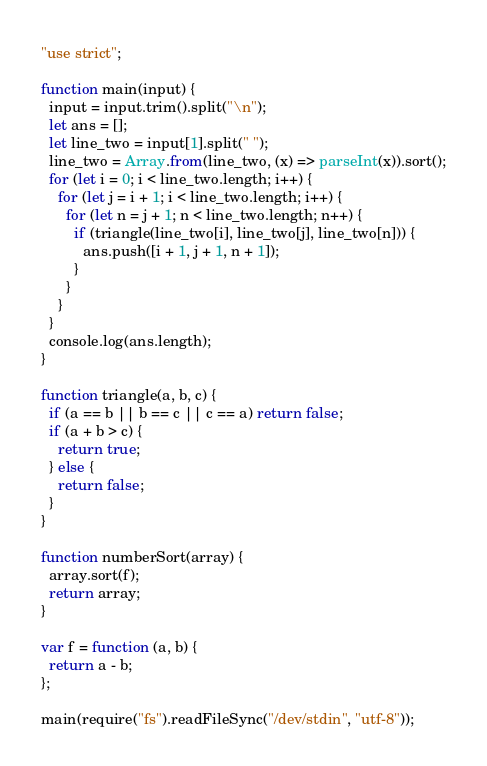Convert code to text. <code><loc_0><loc_0><loc_500><loc_500><_JavaScript_>"use strict";

function main(input) {
  input = input.trim().split("\n");
  let ans = [];
  let line_two = input[1].split(" ");
  line_two = Array.from(line_two, (x) => parseInt(x)).sort();
  for (let i = 0; i < line_two.length; i++) {
    for (let j = i + 1; i < line_two.length; i++) {
      for (let n = j + 1; n < line_two.length; n++) {
        if (triangle(line_two[i], line_two[j], line_two[n])) {
          ans.push([i + 1, j + 1, n + 1]);
        }
      }
    }
  }
  console.log(ans.length);
}

function triangle(a, b, c) {
  if (a == b || b == c || c == a) return false;
  if (a + b > c) {
    return true;
  } else {
    return false;
  }
}

function numberSort(array) {
  array.sort(f);
  return array;
}

var f = function (a, b) {
  return a - b;
};

main(require("fs").readFileSync("/dev/stdin", "utf-8"));
</code> 